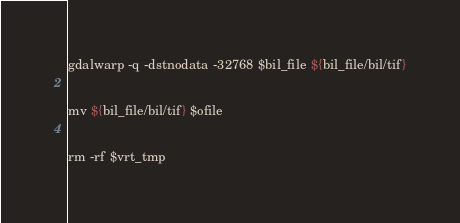<code> <loc_0><loc_0><loc_500><loc_500><_Bash_>gdalwarp -q -dstnodata -32768 $bil_file ${bil_file/bil/tif}

mv ${bil_file/bil/tif} $ofile

rm -rf $vrt_tmp
</code> 